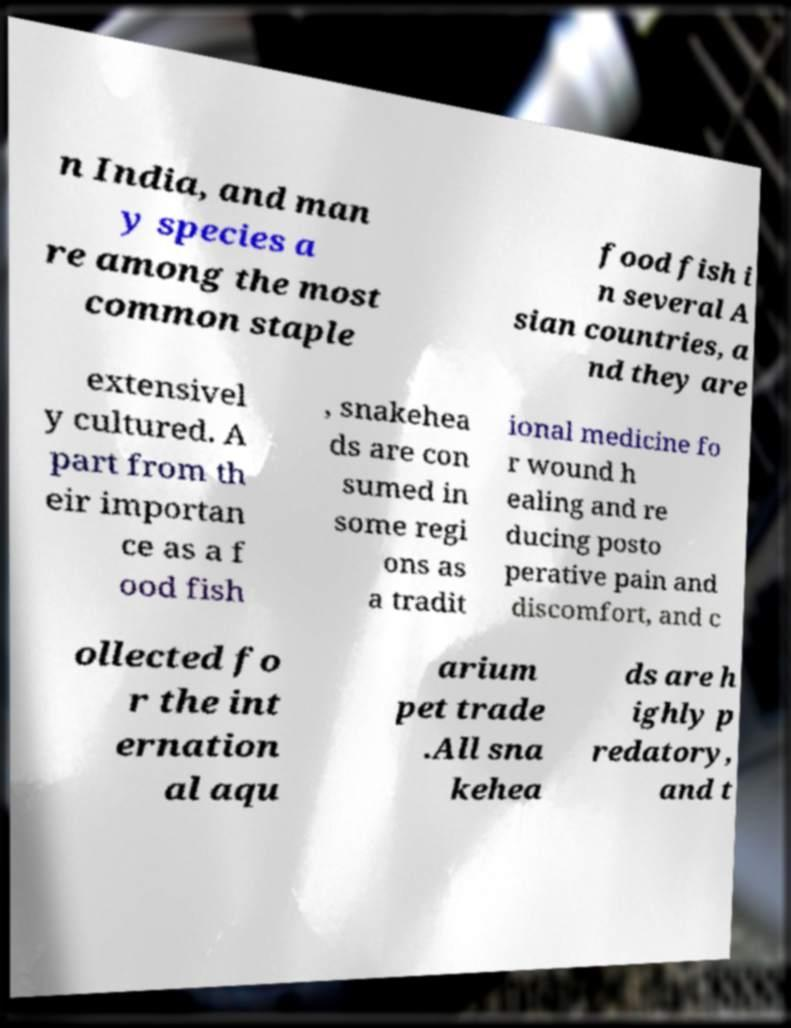What messages or text are displayed in this image? I need them in a readable, typed format. n India, and man y species a re among the most common staple food fish i n several A sian countries, a nd they are extensivel y cultured. A part from th eir importan ce as a f ood fish , snakehea ds are con sumed in some regi ons as a tradit ional medicine fo r wound h ealing and re ducing posto perative pain and discomfort, and c ollected fo r the int ernation al aqu arium pet trade .All sna kehea ds are h ighly p redatory, and t 